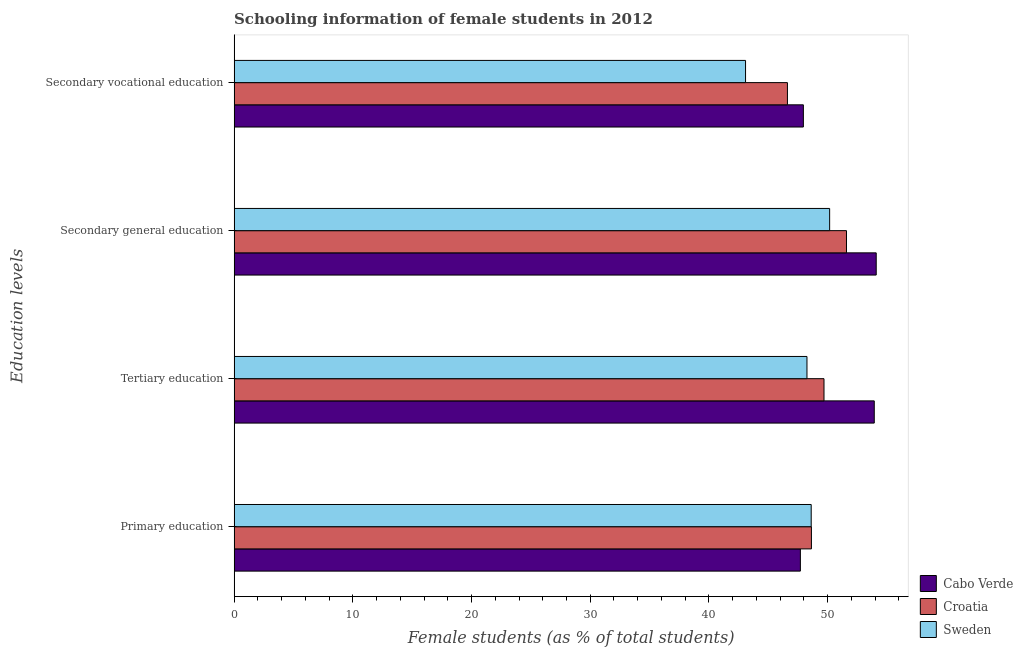How many different coloured bars are there?
Your answer should be compact. 3. How many groups of bars are there?
Provide a short and direct response. 4. Are the number of bars on each tick of the Y-axis equal?
Provide a succinct answer. Yes. How many bars are there on the 1st tick from the top?
Offer a very short reply. 3. How many bars are there on the 3rd tick from the bottom?
Keep it short and to the point. 3. What is the label of the 1st group of bars from the top?
Ensure brevity in your answer.  Secondary vocational education. What is the percentage of female students in primary education in Sweden?
Provide a short and direct response. 48.62. Across all countries, what is the maximum percentage of female students in tertiary education?
Offer a very short reply. 53.93. Across all countries, what is the minimum percentage of female students in primary education?
Ensure brevity in your answer.  47.7. In which country was the percentage of female students in secondary education maximum?
Give a very brief answer. Cabo Verde. In which country was the percentage of female students in primary education minimum?
Offer a terse response. Cabo Verde. What is the total percentage of female students in secondary education in the graph?
Make the answer very short. 155.85. What is the difference between the percentage of female students in secondary education in Cabo Verde and that in Croatia?
Ensure brevity in your answer.  2.51. What is the difference between the percentage of female students in primary education in Croatia and the percentage of female students in tertiary education in Sweden?
Offer a very short reply. 0.38. What is the average percentage of female students in tertiary education per country?
Make the answer very short. 50.63. What is the difference between the percentage of female students in secondary vocational education and percentage of female students in primary education in Sweden?
Provide a short and direct response. -5.53. In how many countries, is the percentage of female students in secondary vocational education greater than 32 %?
Provide a succinct answer. 3. What is the ratio of the percentage of female students in primary education in Cabo Verde to that in Croatia?
Provide a short and direct response. 0.98. Is the percentage of female students in secondary education in Sweden less than that in Croatia?
Your response must be concise. Yes. What is the difference between the highest and the second highest percentage of female students in secondary vocational education?
Ensure brevity in your answer.  1.34. What is the difference between the highest and the lowest percentage of female students in secondary vocational education?
Provide a short and direct response. 4.87. In how many countries, is the percentage of female students in secondary education greater than the average percentage of female students in secondary education taken over all countries?
Ensure brevity in your answer.  1. Is it the case that in every country, the sum of the percentage of female students in secondary vocational education and percentage of female students in tertiary education is greater than the sum of percentage of female students in primary education and percentage of female students in secondary education?
Your response must be concise. No. What does the 2nd bar from the top in Secondary vocational education represents?
Give a very brief answer. Croatia. Is it the case that in every country, the sum of the percentage of female students in primary education and percentage of female students in tertiary education is greater than the percentage of female students in secondary education?
Give a very brief answer. Yes. How many countries are there in the graph?
Your response must be concise. 3. Does the graph contain grids?
Make the answer very short. No. Where does the legend appear in the graph?
Ensure brevity in your answer.  Bottom right. How many legend labels are there?
Give a very brief answer. 3. What is the title of the graph?
Keep it short and to the point. Schooling information of female students in 2012. What is the label or title of the X-axis?
Provide a short and direct response. Female students (as % of total students). What is the label or title of the Y-axis?
Give a very brief answer. Education levels. What is the Female students (as % of total students) in Cabo Verde in Primary education?
Offer a very short reply. 47.7. What is the Female students (as % of total students) in Croatia in Primary education?
Offer a very short reply. 48.64. What is the Female students (as % of total students) of Sweden in Primary education?
Offer a terse response. 48.62. What is the Female students (as % of total students) of Cabo Verde in Tertiary education?
Provide a succinct answer. 53.93. What is the Female students (as % of total students) of Croatia in Tertiary education?
Provide a succinct answer. 49.69. What is the Female students (as % of total students) of Sweden in Tertiary education?
Your answer should be very brief. 48.26. What is the Female students (as % of total students) of Cabo Verde in Secondary general education?
Give a very brief answer. 54.09. What is the Female students (as % of total students) in Croatia in Secondary general education?
Offer a very short reply. 51.59. What is the Female students (as % of total students) of Sweden in Secondary general education?
Keep it short and to the point. 50.17. What is the Female students (as % of total students) of Cabo Verde in Secondary vocational education?
Your answer should be very brief. 47.96. What is the Female students (as % of total students) in Croatia in Secondary vocational education?
Offer a terse response. 46.61. What is the Female students (as % of total students) in Sweden in Secondary vocational education?
Give a very brief answer. 43.09. Across all Education levels, what is the maximum Female students (as % of total students) of Cabo Verde?
Your answer should be compact. 54.09. Across all Education levels, what is the maximum Female students (as % of total students) of Croatia?
Ensure brevity in your answer.  51.59. Across all Education levels, what is the maximum Female students (as % of total students) of Sweden?
Keep it short and to the point. 50.17. Across all Education levels, what is the minimum Female students (as % of total students) in Cabo Verde?
Offer a very short reply. 47.7. Across all Education levels, what is the minimum Female students (as % of total students) of Croatia?
Make the answer very short. 46.61. Across all Education levels, what is the minimum Female students (as % of total students) of Sweden?
Your response must be concise. 43.09. What is the total Female students (as % of total students) of Cabo Verde in the graph?
Ensure brevity in your answer.  203.68. What is the total Female students (as % of total students) of Croatia in the graph?
Provide a short and direct response. 196.53. What is the total Female students (as % of total students) of Sweden in the graph?
Your answer should be compact. 190.13. What is the difference between the Female students (as % of total students) in Cabo Verde in Primary education and that in Tertiary education?
Offer a terse response. -6.22. What is the difference between the Female students (as % of total students) in Croatia in Primary education and that in Tertiary education?
Make the answer very short. -1.06. What is the difference between the Female students (as % of total students) in Sweden in Primary education and that in Tertiary education?
Make the answer very short. 0.36. What is the difference between the Female students (as % of total students) of Cabo Verde in Primary education and that in Secondary general education?
Your answer should be compact. -6.39. What is the difference between the Female students (as % of total students) of Croatia in Primary education and that in Secondary general education?
Your answer should be compact. -2.95. What is the difference between the Female students (as % of total students) in Sweden in Primary education and that in Secondary general education?
Make the answer very short. -1.55. What is the difference between the Female students (as % of total students) in Cabo Verde in Primary education and that in Secondary vocational education?
Provide a short and direct response. -0.25. What is the difference between the Female students (as % of total students) in Croatia in Primary education and that in Secondary vocational education?
Make the answer very short. 2.02. What is the difference between the Female students (as % of total students) in Sweden in Primary education and that in Secondary vocational education?
Your answer should be compact. 5.53. What is the difference between the Female students (as % of total students) in Cabo Verde in Tertiary education and that in Secondary general education?
Your answer should be very brief. -0.16. What is the difference between the Female students (as % of total students) in Croatia in Tertiary education and that in Secondary general education?
Provide a short and direct response. -1.89. What is the difference between the Female students (as % of total students) of Sweden in Tertiary education and that in Secondary general education?
Provide a succinct answer. -1.91. What is the difference between the Female students (as % of total students) of Cabo Verde in Tertiary education and that in Secondary vocational education?
Keep it short and to the point. 5.97. What is the difference between the Female students (as % of total students) in Croatia in Tertiary education and that in Secondary vocational education?
Give a very brief answer. 3.08. What is the difference between the Female students (as % of total students) in Sweden in Tertiary education and that in Secondary vocational education?
Your response must be concise. 5.17. What is the difference between the Female students (as % of total students) of Cabo Verde in Secondary general education and that in Secondary vocational education?
Give a very brief answer. 6.14. What is the difference between the Female students (as % of total students) in Croatia in Secondary general education and that in Secondary vocational education?
Offer a terse response. 4.97. What is the difference between the Female students (as % of total students) of Sweden in Secondary general education and that in Secondary vocational education?
Your answer should be very brief. 7.08. What is the difference between the Female students (as % of total students) of Cabo Verde in Primary education and the Female students (as % of total students) of Croatia in Tertiary education?
Offer a terse response. -1.99. What is the difference between the Female students (as % of total students) in Cabo Verde in Primary education and the Female students (as % of total students) in Sweden in Tertiary education?
Give a very brief answer. -0.56. What is the difference between the Female students (as % of total students) of Croatia in Primary education and the Female students (as % of total students) of Sweden in Tertiary education?
Offer a very short reply. 0.38. What is the difference between the Female students (as % of total students) of Cabo Verde in Primary education and the Female students (as % of total students) of Croatia in Secondary general education?
Your answer should be compact. -3.88. What is the difference between the Female students (as % of total students) of Cabo Verde in Primary education and the Female students (as % of total students) of Sweden in Secondary general education?
Your answer should be compact. -2.46. What is the difference between the Female students (as % of total students) of Croatia in Primary education and the Female students (as % of total students) of Sweden in Secondary general education?
Ensure brevity in your answer.  -1.53. What is the difference between the Female students (as % of total students) in Cabo Verde in Primary education and the Female students (as % of total students) in Croatia in Secondary vocational education?
Provide a succinct answer. 1.09. What is the difference between the Female students (as % of total students) in Cabo Verde in Primary education and the Female students (as % of total students) in Sweden in Secondary vocational education?
Ensure brevity in your answer.  4.62. What is the difference between the Female students (as % of total students) in Croatia in Primary education and the Female students (as % of total students) in Sweden in Secondary vocational education?
Ensure brevity in your answer.  5.55. What is the difference between the Female students (as % of total students) in Cabo Verde in Tertiary education and the Female students (as % of total students) in Croatia in Secondary general education?
Give a very brief answer. 2.34. What is the difference between the Female students (as % of total students) in Cabo Verde in Tertiary education and the Female students (as % of total students) in Sweden in Secondary general education?
Offer a very short reply. 3.76. What is the difference between the Female students (as % of total students) in Croatia in Tertiary education and the Female students (as % of total students) in Sweden in Secondary general education?
Ensure brevity in your answer.  -0.47. What is the difference between the Female students (as % of total students) in Cabo Verde in Tertiary education and the Female students (as % of total students) in Croatia in Secondary vocational education?
Provide a succinct answer. 7.32. What is the difference between the Female students (as % of total students) of Cabo Verde in Tertiary education and the Female students (as % of total students) of Sweden in Secondary vocational education?
Offer a very short reply. 10.84. What is the difference between the Female students (as % of total students) of Croatia in Tertiary education and the Female students (as % of total students) of Sweden in Secondary vocational education?
Your answer should be compact. 6.61. What is the difference between the Female students (as % of total students) in Cabo Verde in Secondary general education and the Female students (as % of total students) in Croatia in Secondary vocational education?
Offer a terse response. 7.48. What is the difference between the Female students (as % of total students) in Cabo Verde in Secondary general education and the Female students (as % of total students) in Sweden in Secondary vocational education?
Keep it short and to the point. 11.01. What is the difference between the Female students (as % of total students) in Croatia in Secondary general education and the Female students (as % of total students) in Sweden in Secondary vocational education?
Ensure brevity in your answer.  8.5. What is the average Female students (as % of total students) in Cabo Verde per Education levels?
Provide a succinct answer. 50.92. What is the average Female students (as % of total students) in Croatia per Education levels?
Your response must be concise. 49.13. What is the average Female students (as % of total students) in Sweden per Education levels?
Make the answer very short. 47.53. What is the difference between the Female students (as % of total students) of Cabo Verde and Female students (as % of total students) of Croatia in Primary education?
Your answer should be very brief. -0.93. What is the difference between the Female students (as % of total students) in Cabo Verde and Female students (as % of total students) in Sweden in Primary education?
Ensure brevity in your answer.  -0.91. What is the difference between the Female students (as % of total students) in Croatia and Female students (as % of total students) in Sweden in Primary education?
Your response must be concise. 0.02. What is the difference between the Female students (as % of total students) in Cabo Verde and Female students (as % of total students) in Croatia in Tertiary education?
Make the answer very short. 4.23. What is the difference between the Female students (as % of total students) of Cabo Verde and Female students (as % of total students) of Sweden in Tertiary education?
Provide a succinct answer. 5.67. What is the difference between the Female students (as % of total students) of Croatia and Female students (as % of total students) of Sweden in Tertiary education?
Your answer should be very brief. 1.43. What is the difference between the Female students (as % of total students) in Cabo Verde and Female students (as % of total students) in Croatia in Secondary general education?
Your response must be concise. 2.51. What is the difference between the Female students (as % of total students) of Cabo Verde and Female students (as % of total students) of Sweden in Secondary general education?
Make the answer very short. 3.92. What is the difference between the Female students (as % of total students) of Croatia and Female students (as % of total students) of Sweden in Secondary general education?
Your answer should be very brief. 1.42. What is the difference between the Female students (as % of total students) in Cabo Verde and Female students (as % of total students) in Croatia in Secondary vocational education?
Offer a terse response. 1.34. What is the difference between the Female students (as % of total students) of Cabo Verde and Female students (as % of total students) of Sweden in Secondary vocational education?
Ensure brevity in your answer.  4.87. What is the difference between the Female students (as % of total students) of Croatia and Female students (as % of total students) of Sweden in Secondary vocational education?
Your answer should be very brief. 3.53. What is the ratio of the Female students (as % of total students) in Cabo Verde in Primary education to that in Tertiary education?
Provide a succinct answer. 0.88. What is the ratio of the Female students (as % of total students) of Croatia in Primary education to that in Tertiary education?
Your answer should be very brief. 0.98. What is the ratio of the Female students (as % of total students) of Sweden in Primary education to that in Tertiary education?
Your answer should be compact. 1.01. What is the ratio of the Female students (as % of total students) of Cabo Verde in Primary education to that in Secondary general education?
Give a very brief answer. 0.88. What is the ratio of the Female students (as % of total students) in Croatia in Primary education to that in Secondary general education?
Your response must be concise. 0.94. What is the ratio of the Female students (as % of total students) of Croatia in Primary education to that in Secondary vocational education?
Keep it short and to the point. 1.04. What is the ratio of the Female students (as % of total students) of Sweden in Primary education to that in Secondary vocational education?
Your answer should be compact. 1.13. What is the ratio of the Female students (as % of total students) of Cabo Verde in Tertiary education to that in Secondary general education?
Make the answer very short. 1. What is the ratio of the Female students (as % of total students) in Croatia in Tertiary education to that in Secondary general education?
Keep it short and to the point. 0.96. What is the ratio of the Female students (as % of total students) in Sweden in Tertiary education to that in Secondary general education?
Your response must be concise. 0.96. What is the ratio of the Female students (as % of total students) in Cabo Verde in Tertiary education to that in Secondary vocational education?
Provide a succinct answer. 1.12. What is the ratio of the Female students (as % of total students) in Croatia in Tertiary education to that in Secondary vocational education?
Offer a terse response. 1.07. What is the ratio of the Female students (as % of total students) of Sweden in Tertiary education to that in Secondary vocational education?
Give a very brief answer. 1.12. What is the ratio of the Female students (as % of total students) of Cabo Verde in Secondary general education to that in Secondary vocational education?
Provide a short and direct response. 1.13. What is the ratio of the Female students (as % of total students) of Croatia in Secondary general education to that in Secondary vocational education?
Ensure brevity in your answer.  1.11. What is the ratio of the Female students (as % of total students) in Sweden in Secondary general education to that in Secondary vocational education?
Offer a terse response. 1.16. What is the difference between the highest and the second highest Female students (as % of total students) of Cabo Verde?
Make the answer very short. 0.16. What is the difference between the highest and the second highest Female students (as % of total students) in Croatia?
Offer a very short reply. 1.89. What is the difference between the highest and the second highest Female students (as % of total students) of Sweden?
Keep it short and to the point. 1.55. What is the difference between the highest and the lowest Female students (as % of total students) in Cabo Verde?
Ensure brevity in your answer.  6.39. What is the difference between the highest and the lowest Female students (as % of total students) of Croatia?
Make the answer very short. 4.97. What is the difference between the highest and the lowest Female students (as % of total students) in Sweden?
Offer a very short reply. 7.08. 